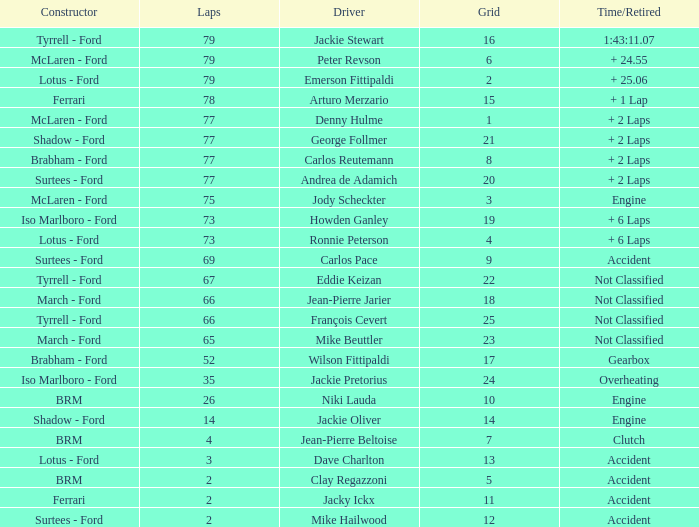How much time is required for less than 35 laps and less than 10 grids? Clutch, Accident. 